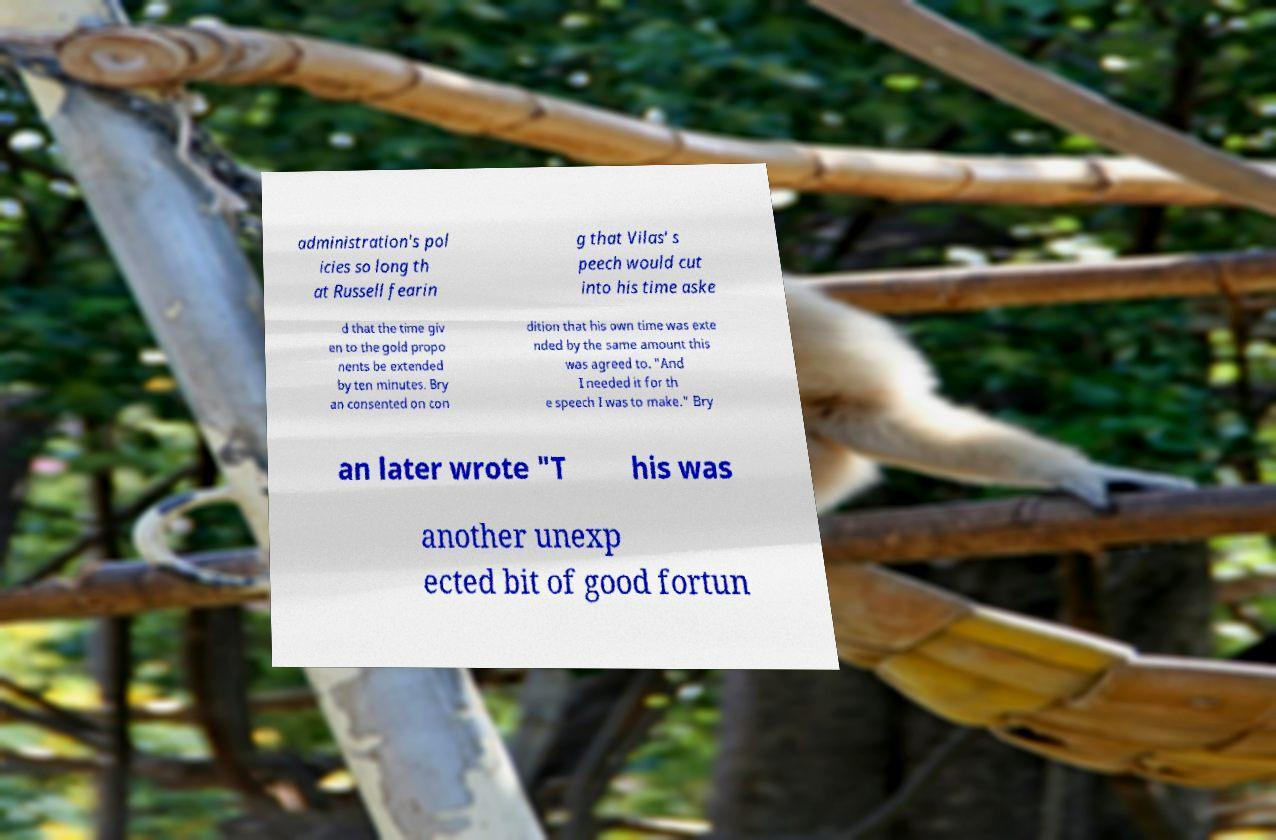Can you accurately transcribe the text from the provided image for me? administration's pol icies so long th at Russell fearin g that Vilas' s peech would cut into his time aske d that the time giv en to the gold propo nents be extended by ten minutes. Bry an consented on con dition that his own time was exte nded by the same amount this was agreed to. "And I needed it for th e speech I was to make." Bry an later wrote "T his was another unexp ected bit of good fortun 